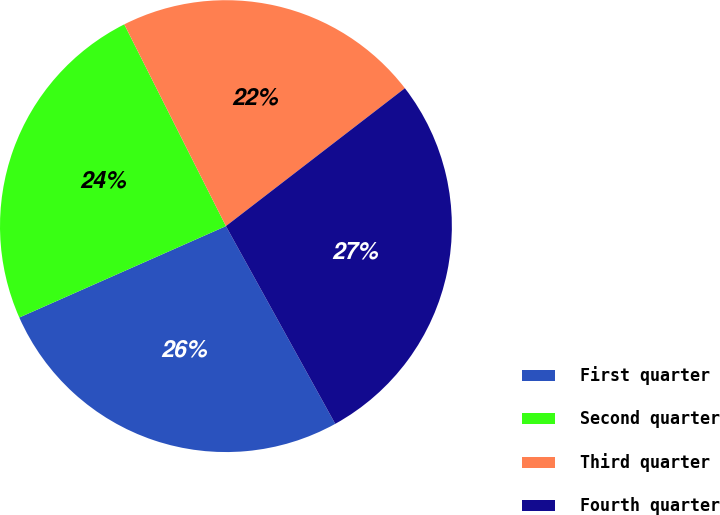Convert chart. <chart><loc_0><loc_0><loc_500><loc_500><pie_chart><fcel>First quarter<fcel>Second quarter<fcel>Third quarter<fcel>Fourth quarter<nl><fcel>26.41%<fcel>24.2%<fcel>21.98%<fcel>27.41%<nl></chart> 